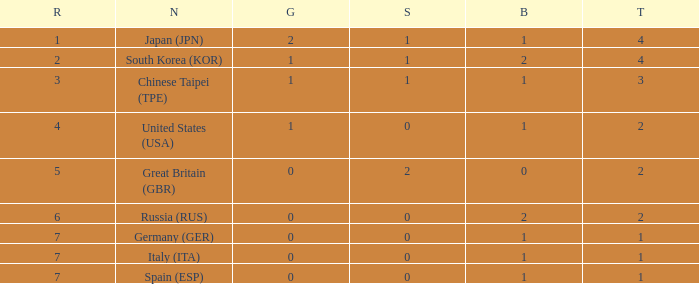What is the rank of the country with more than 2 medals, and 2 gold medals? 1.0. 